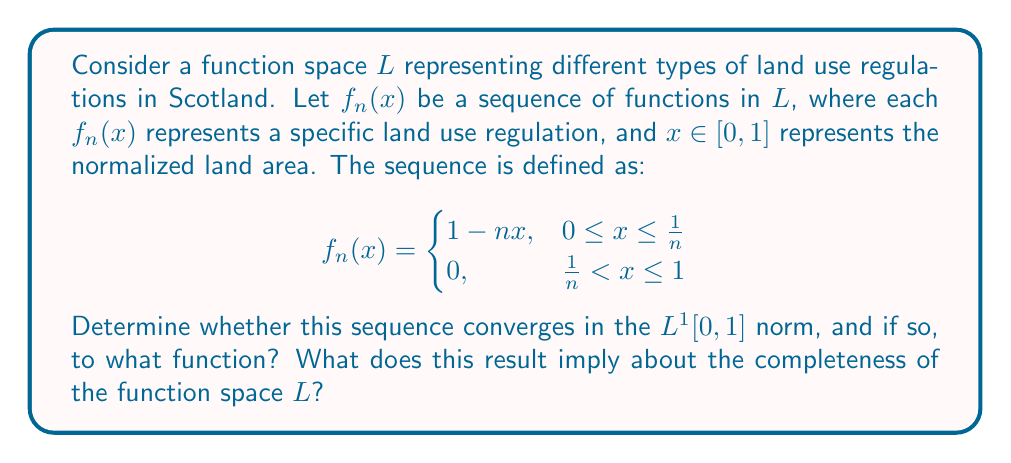Could you help me with this problem? To solve this problem, we'll follow these steps:

1) First, let's determine if the sequence converges pointwise.
   For any fixed $x \in (0,1]$, as $n \to \infty$, $\frac{1}{n} \to 0$. So for large enough $n$, $x > \frac{1}{n}$, and thus $f_n(x) = 0$.
   For $x = 0$, $f_n(0) = 1$ for all $n$.
   Therefore, the pointwise limit is:
   $$f(x) = \begin{cases}
   1, & x = 0 \\
   0, & 0 < x \leq 1
   \end{cases}$$

2) Now, let's check if this convergence is in the $L^1[0,1]$ norm.
   We need to calculate $\lim_{n \to \infty} \int_0^1 |f_n(x) - f(x)| dx$.

3) Let's split this integral:
   $$\int_0^1 |f_n(x) - f(x)| dx = \int_0^{\frac{1}{n}} |1-nx-1| dx + \int_{\frac{1}{n}}^1 |0-0| dx$$

4) Simplifying:
   $$\int_0^1 |f_n(x) - f(x)| dx = \int_0^{\frac{1}{n}} nx dx = \left. \frac{nx^2}{2} \right|_0^{\frac{1}{n}} = \frac{1}{2n}$$

5) As $n \to \infty$, $\frac{1}{2n} \to 0$.

6) Therefore, $f_n$ converges to $f$ in the $L^1[0,1]$ norm.

This result implies that the function space $L$ is complete with respect to the $L^1[0,1]$ norm. Completeness means that every Cauchy sequence in the space converges to an element of the space. In this case, we've shown that our sequence converges to a function in $L^1[0,1]$, which is indeed a complete space.

From a historical and legal perspective, this completeness suggests that as land use regulations evolve over time (represented by the sequence of functions), they tend towards a limiting set of regulations (the limit function). The fact that the limit function is discontinuous at 0 might represent a fundamental distinction between unregulated (or minimally regulated) land use and regulated land use.
Answer: The sequence $f_n(x)$ converges in the $L^1[0,1]$ norm to the function:
$$f(x) = \begin{cases}
1, & x = 0 \\
0, & 0 < x \leq 1
\end{cases}$$
This result implies that the function space $L$ is complete with respect to the $L^1[0,1]$ norm. 